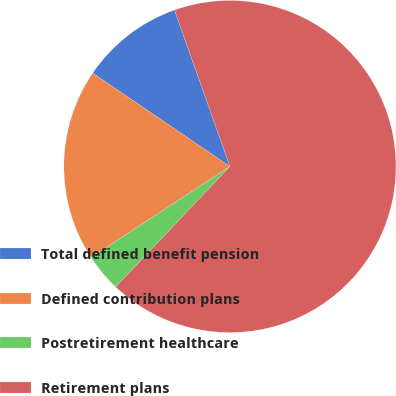<chart> <loc_0><loc_0><loc_500><loc_500><pie_chart><fcel>Total defined benefit pension<fcel>Defined contribution plans<fcel>Postretirement healthcare<fcel>Retirement plans<nl><fcel>10.07%<fcel>18.74%<fcel>3.69%<fcel>67.49%<nl></chart> 